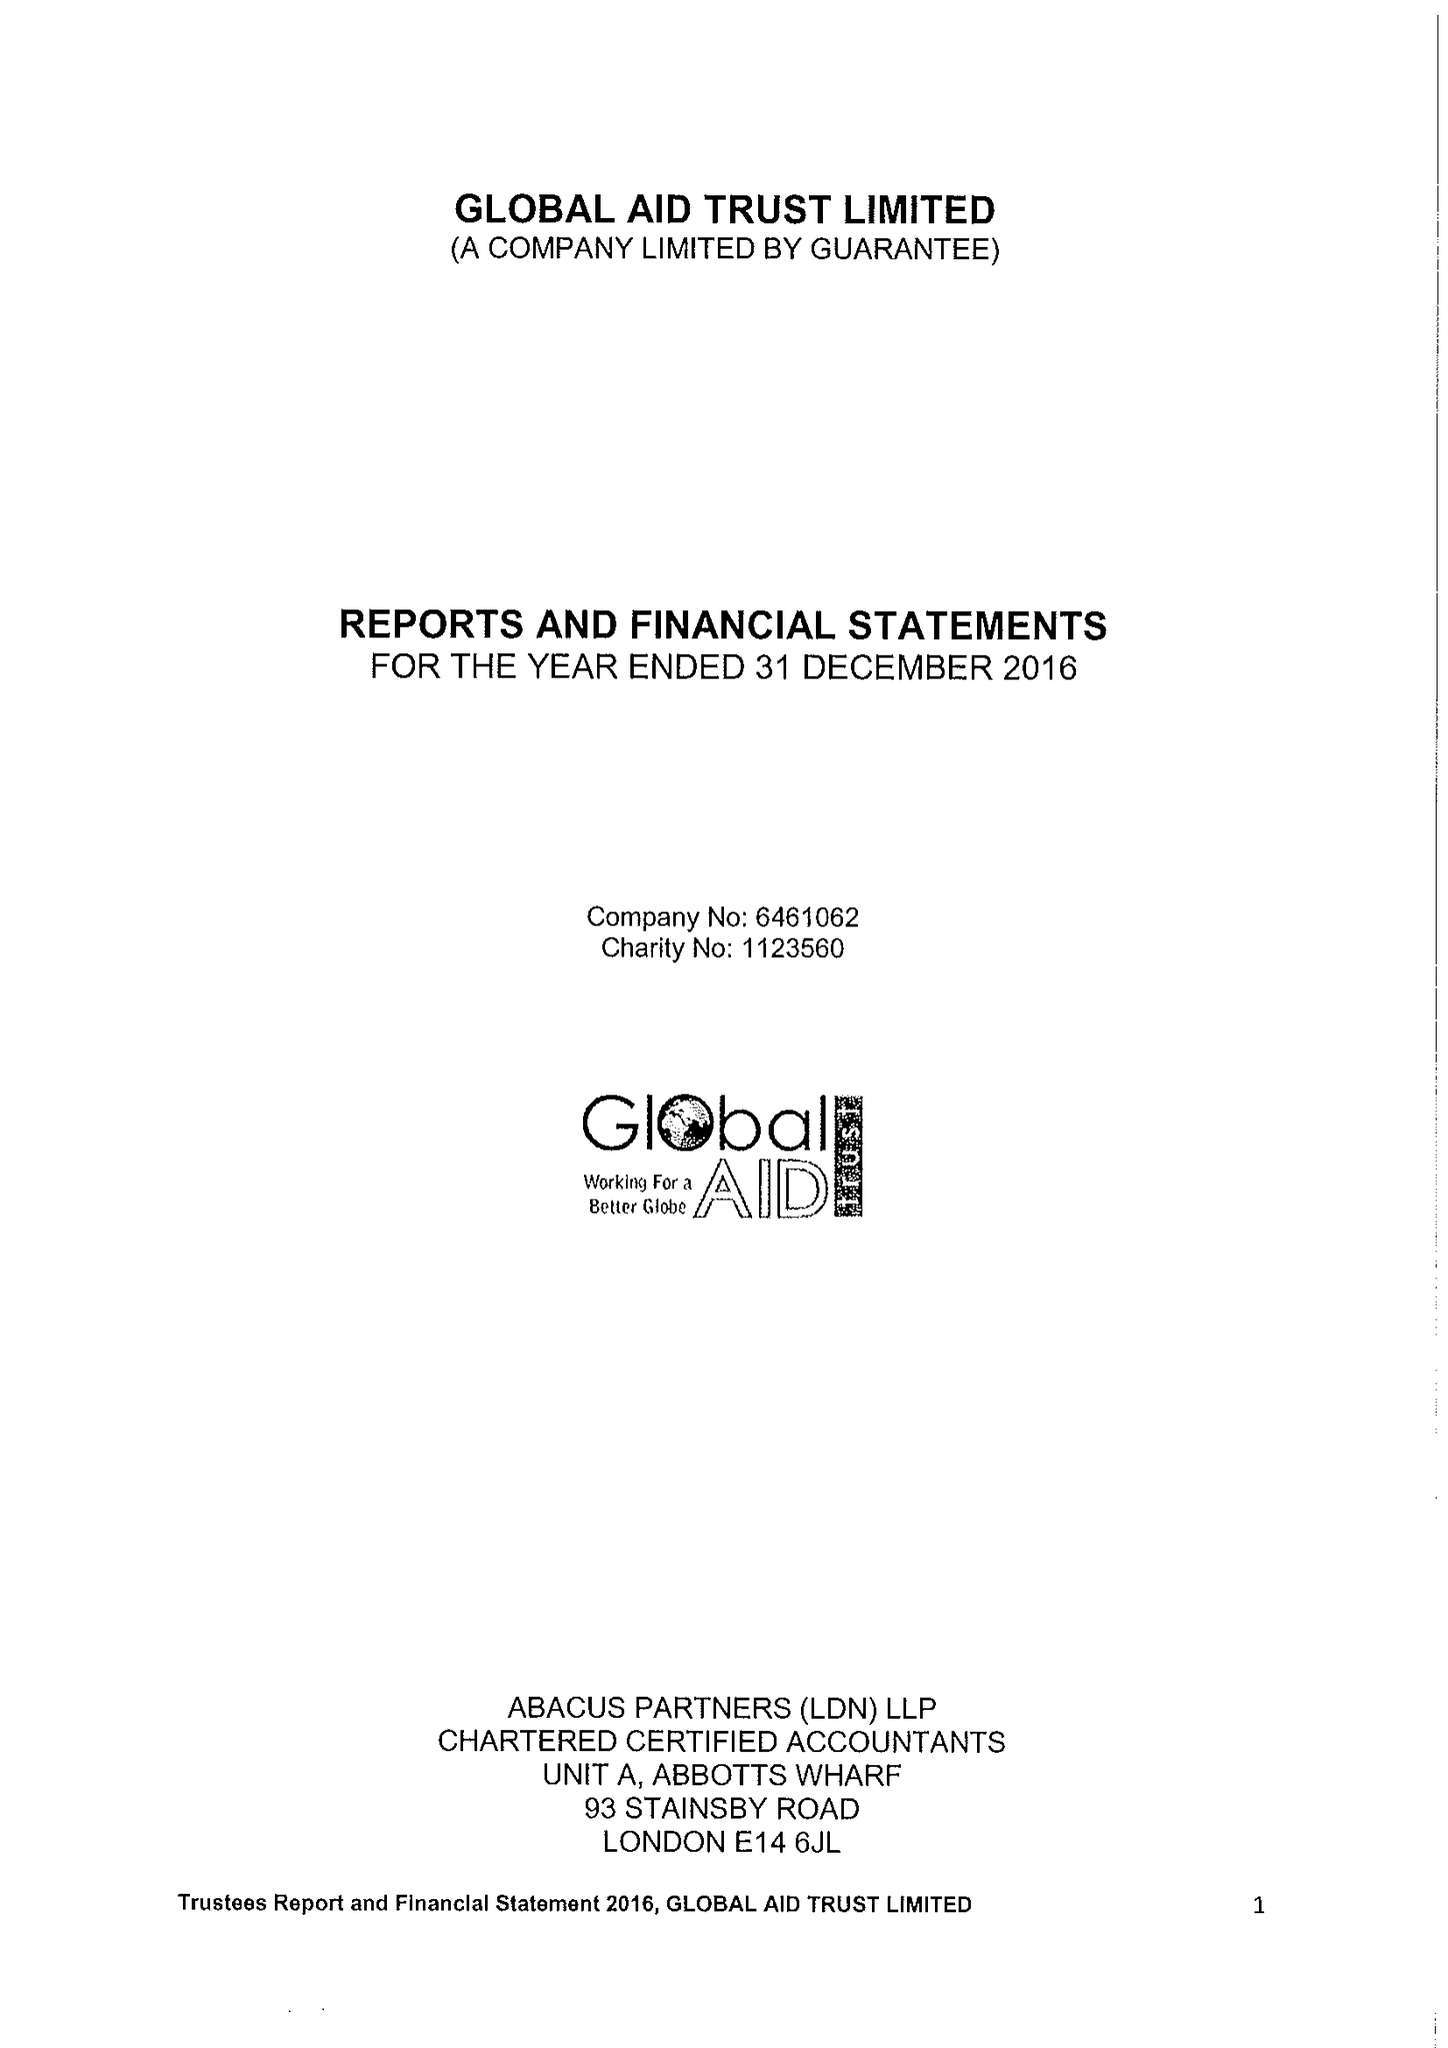What is the value for the charity_number?
Answer the question using a single word or phrase. 1123560 